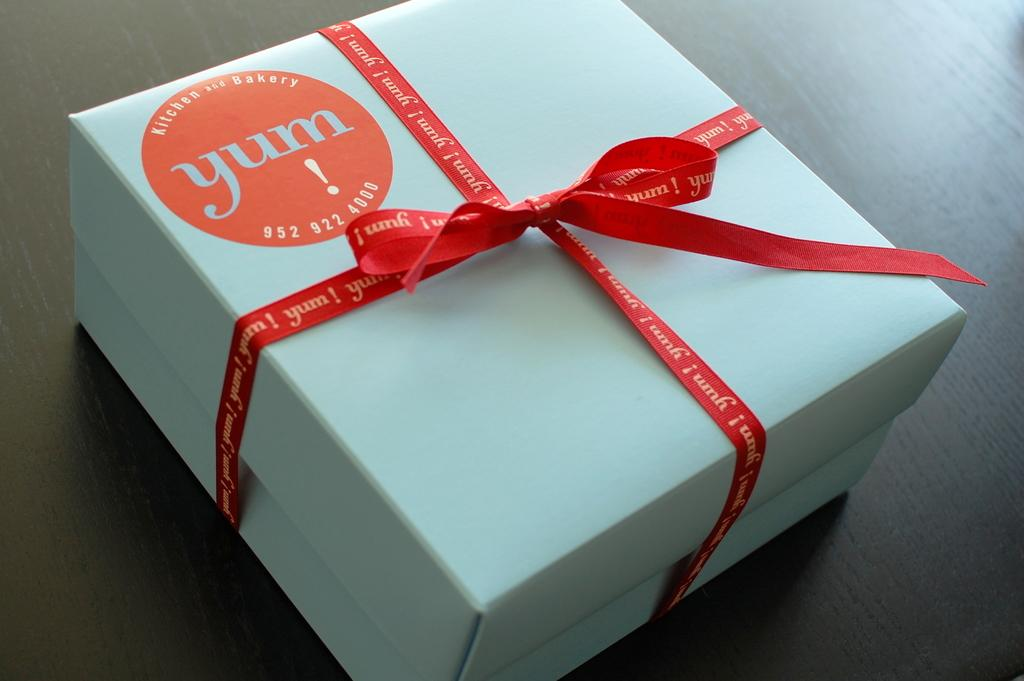<image>
Provide a brief description of the given image. White box with an orange bow from "yum!". 